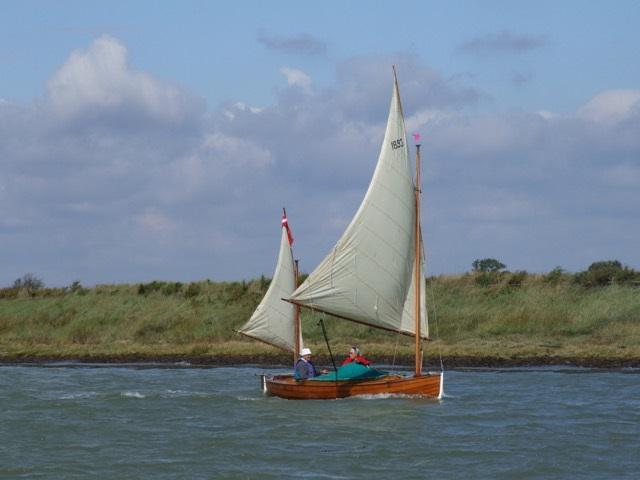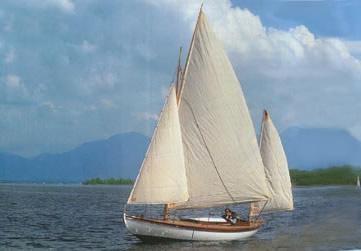The first image is the image on the left, the second image is the image on the right. For the images shown, is this caption "In one image, at least one person is sailing on rough water in a white boat with at least two red sails, the largest one with two rows of thin vertical lines." true? Answer yes or no. No. The first image is the image on the left, the second image is the image on the right. Evaluate the accuracy of this statement regarding the images: "The body of the boat in the image on the right is white.". Is it true? Answer yes or no. Yes. 